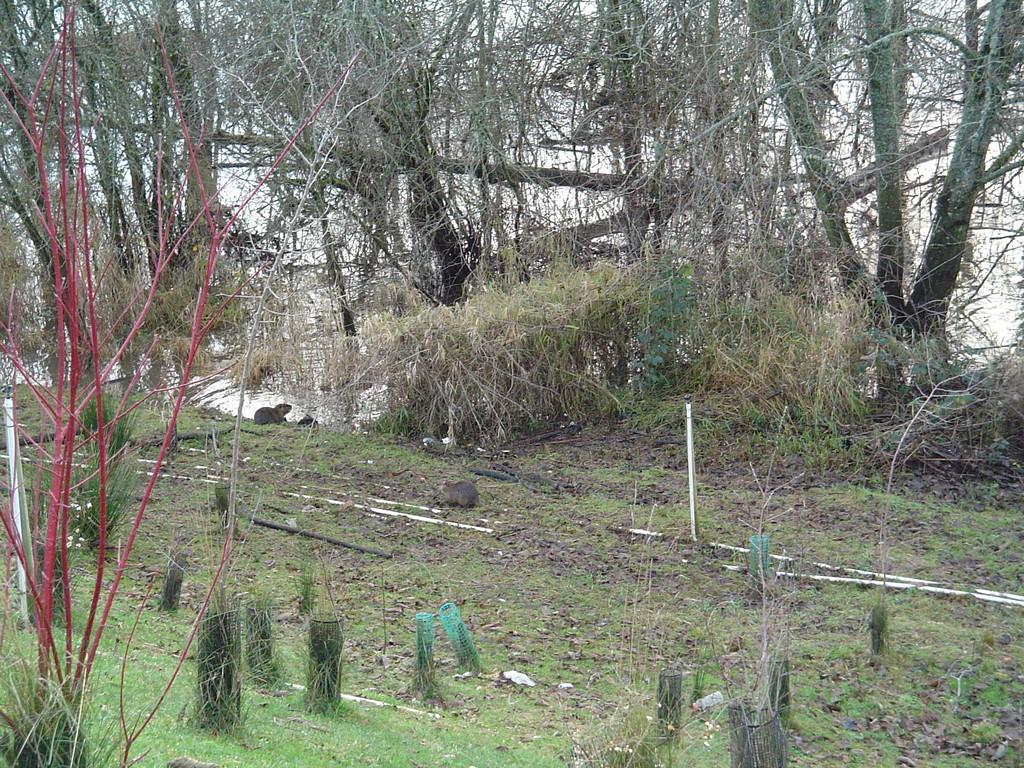What type of vegetation can be seen in the image? There are plants and trees in the image. What natural element is visible in the image? There is water visible in the image. What type of throat condition can be seen in the image? There is no throat condition present in the image; it features plants, trees, and water. What type of bubble is visible in the image? There are no bubbles present in the image. 